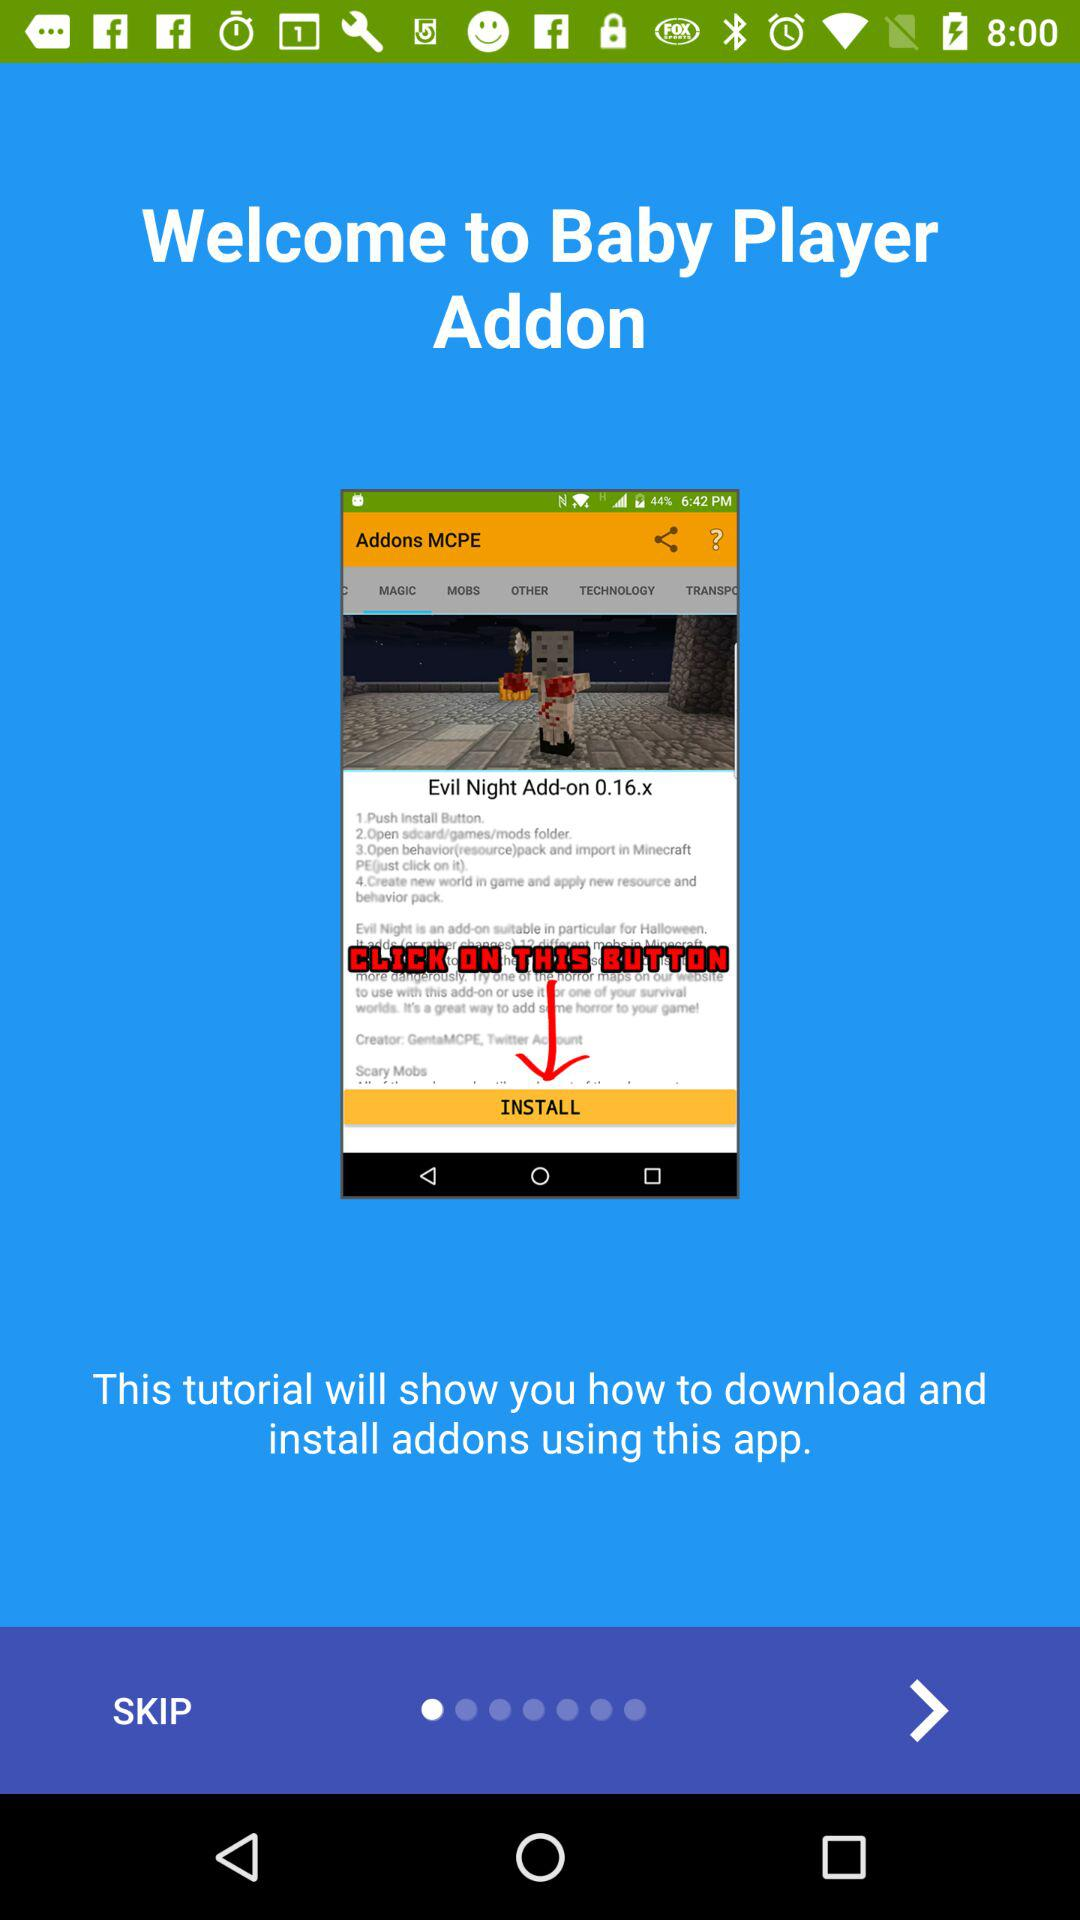What is the name of the application? The name of the application is "Baby Player Addon". 